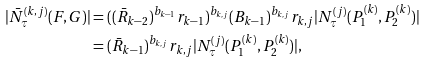<formula> <loc_0><loc_0><loc_500><loc_500>| \bar { N } _ { \tau } ^ { ( k , j ) } ( F , G ) | & = ( ( \bar { R } _ { k - 2 } ) ^ { b _ { k - 1 } } r _ { k - 1 } ) ^ { b _ { k , j } } ( B _ { k - 1 } ) ^ { b _ { k , j } } r _ { k , j } | N _ { \tau } ^ { ( j ) } ( P _ { 1 } ^ { ( k ) } , P _ { 2 } ^ { ( k ) } ) | \\ & = ( \bar { R } _ { k - 1 } ) ^ { b _ { k , j } } r _ { k , j } | N _ { \tau } ^ { ( j ) } ( P _ { 1 } ^ { ( k ) } , P _ { 2 } ^ { ( k ) } ) | ,</formula> 